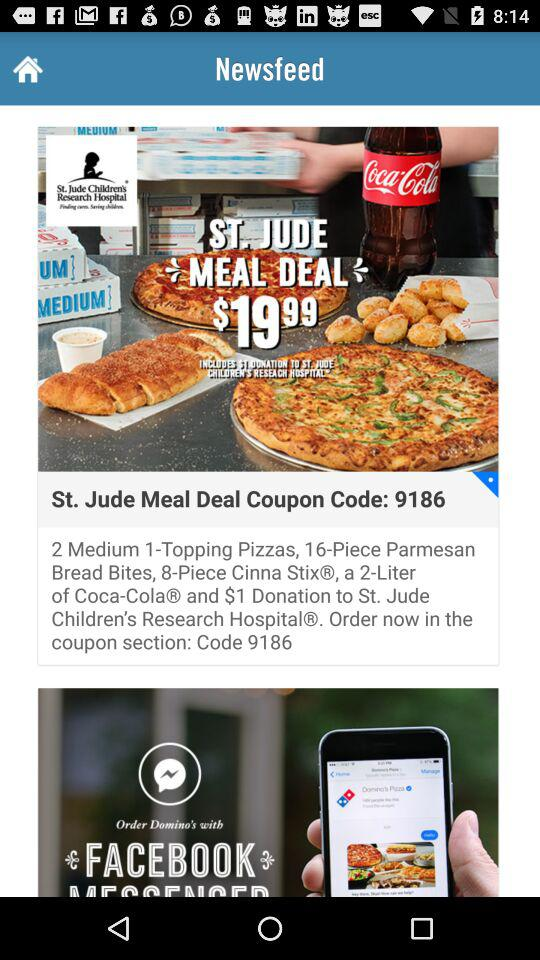What is the quantity of "Coco-Cola"? The quantity of "Coca-Cola" is 2 liters. 